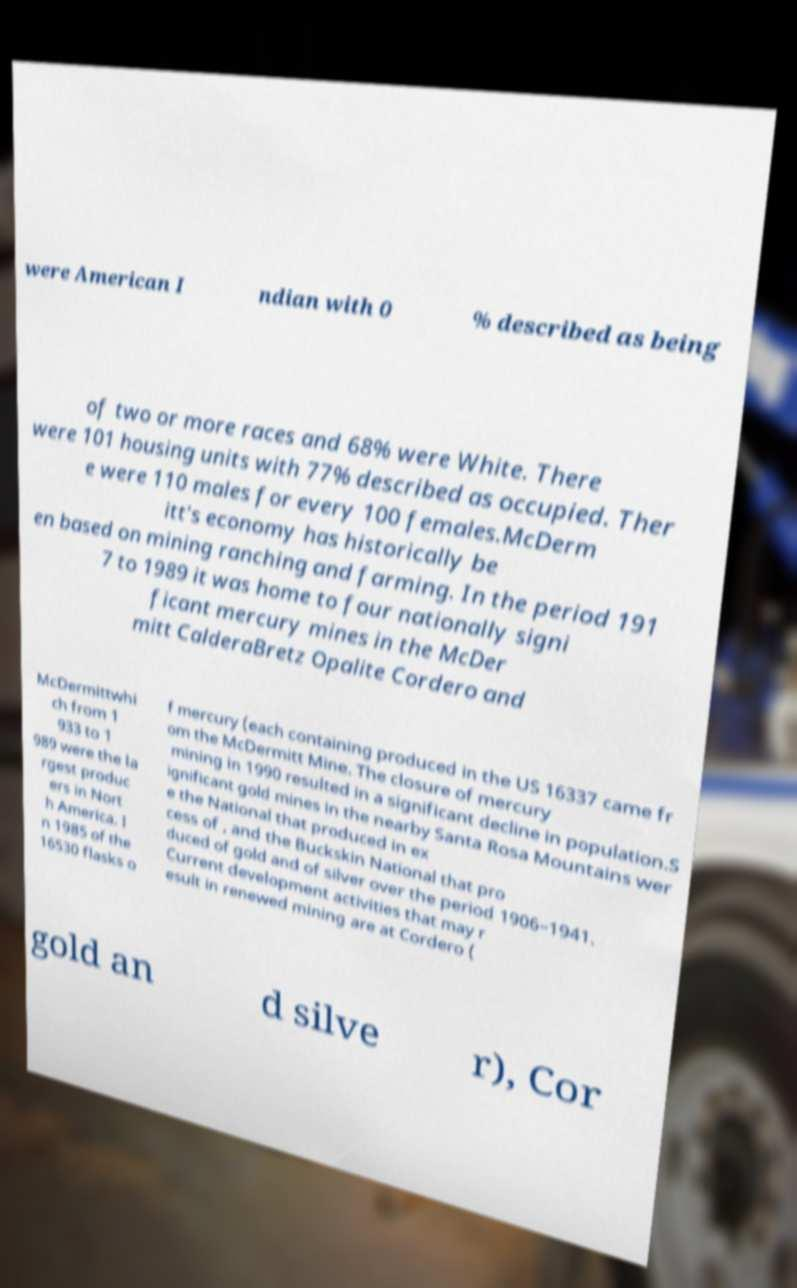For documentation purposes, I need the text within this image transcribed. Could you provide that? were American I ndian with 0 % described as being of two or more races and 68% were White. There were 101 housing units with 77% described as occupied. Ther e were 110 males for every 100 females.McDerm itt's economy has historically be en based on mining ranching and farming. In the period 191 7 to 1989 it was home to four nationally signi ficant mercury mines in the McDer mitt CalderaBretz Opalite Cordero and McDermittwhi ch from 1 933 to 1 989 were the la rgest produc ers in Nort h America. I n 1985 of the 16530 flasks o f mercury (each containing produced in the US 16337 came fr om the McDermitt Mine. The closure of mercury mining in 1990 resulted in a significant decline in population.S ignificant gold mines in the nearby Santa Rosa Mountains wer e the National that produced in ex cess of , and the Buckskin National that pro duced of gold and of silver over the period 1906–1941. Current development activities that may r esult in renewed mining are at Cordero ( gold an d silve r), Cor 